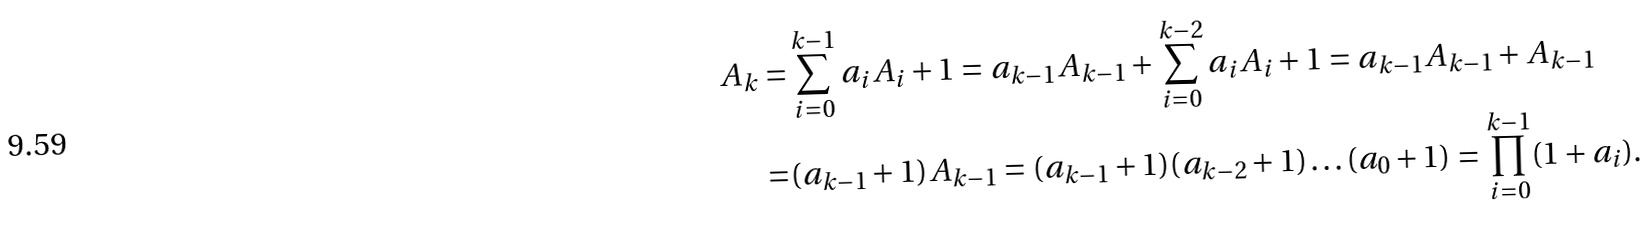Convert formula to latex. <formula><loc_0><loc_0><loc_500><loc_500>A _ { k } = & \sum _ { i = 0 } ^ { k - 1 } a _ { i } A _ { i } + 1 = a _ { k - 1 } A _ { k - 1 } + \sum _ { i = 0 } ^ { k - 2 } a _ { i } A _ { i } + 1 = a _ { k - 1 } A _ { k - 1 } + A _ { k - 1 } \\ = & ( a _ { k - 1 } + 1 ) A _ { k - 1 } = ( a _ { k - 1 } + 1 ) ( a _ { k - 2 } + 1 ) \dots ( a _ { 0 } + 1 ) = \prod _ { i = 0 } ^ { k - 1 } ( 1 + a _ { i } ) .</formula> 